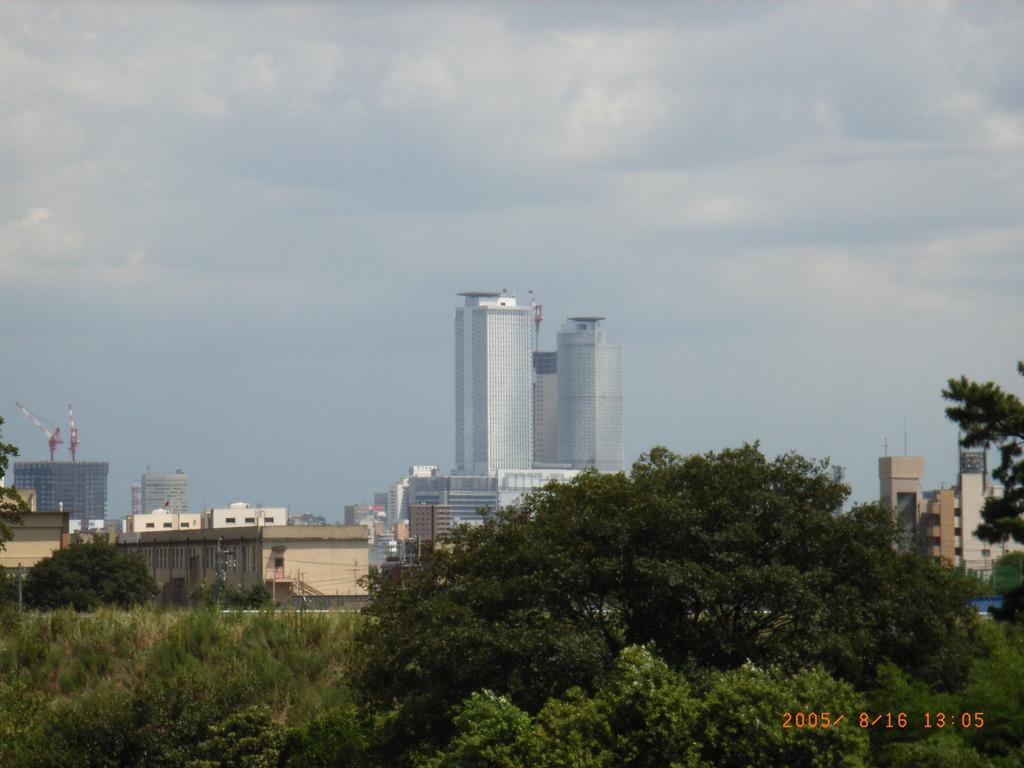Please provide a concise description of this image. in this image there are some trees at bottom of this image and there are some buildings in the background and there is a cloudy sky at top of this image. There are crane machines at left side of this image. 